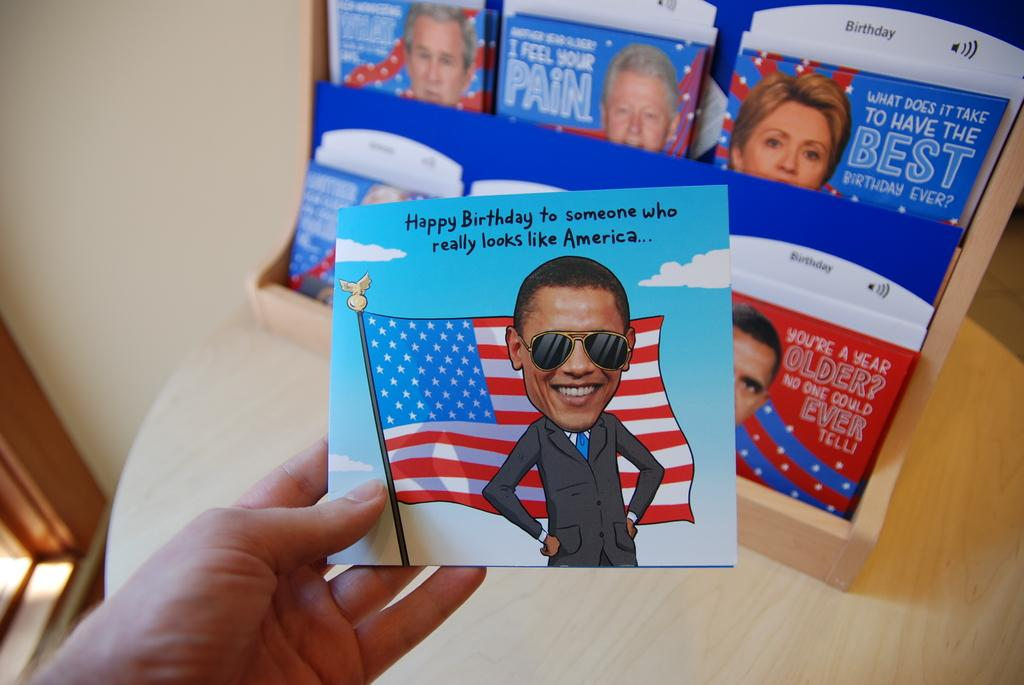What is the person holding in the image? There is a hand holding a paper in the image. What is depicted on the paper? The paper has a person and a flag on it. What piece of furniture is present in the image? There is a table in the image. What can be found on the table besides the hand holding the paper? The table contains some magazines. Can you see a pig playing basketball on the table in the image? No, there is no pig or basketball present in the image. 